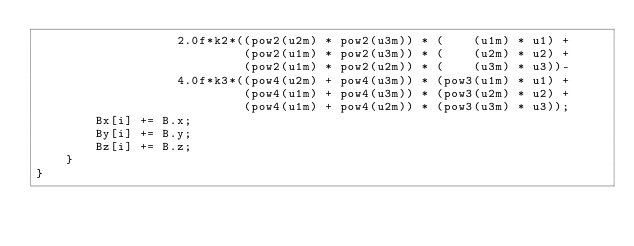Convert code to text. <code><loc_0><loc_0><loc_500><loc_500><_Cuda_>                   2.0f*k2*((pow2(u2m) * pow2(u3m)) * (    (u1m) * u1) +
                            (pow2(u1m) * pow2(u3m)) * (    (u2m) * u2) +
                            (pow2(u1m) * pow2(u2m)) * (    (u3m) * u3))-
                   4.0f*k3*((pow4(u2m) + pow4(u3m)) * (pow3(u1m) * u1) +
                            (pow4(u1m) + pow4(u3m)) * (pow3(u2m) * u2) +
                            (pow4(u1m) + pow4(u2m)) * (pow3(u3m) * u3));
        Bx[i] += B.x;
        By[i] += B.y;
        Bz[i] += B.z;
    }
}
</code> 